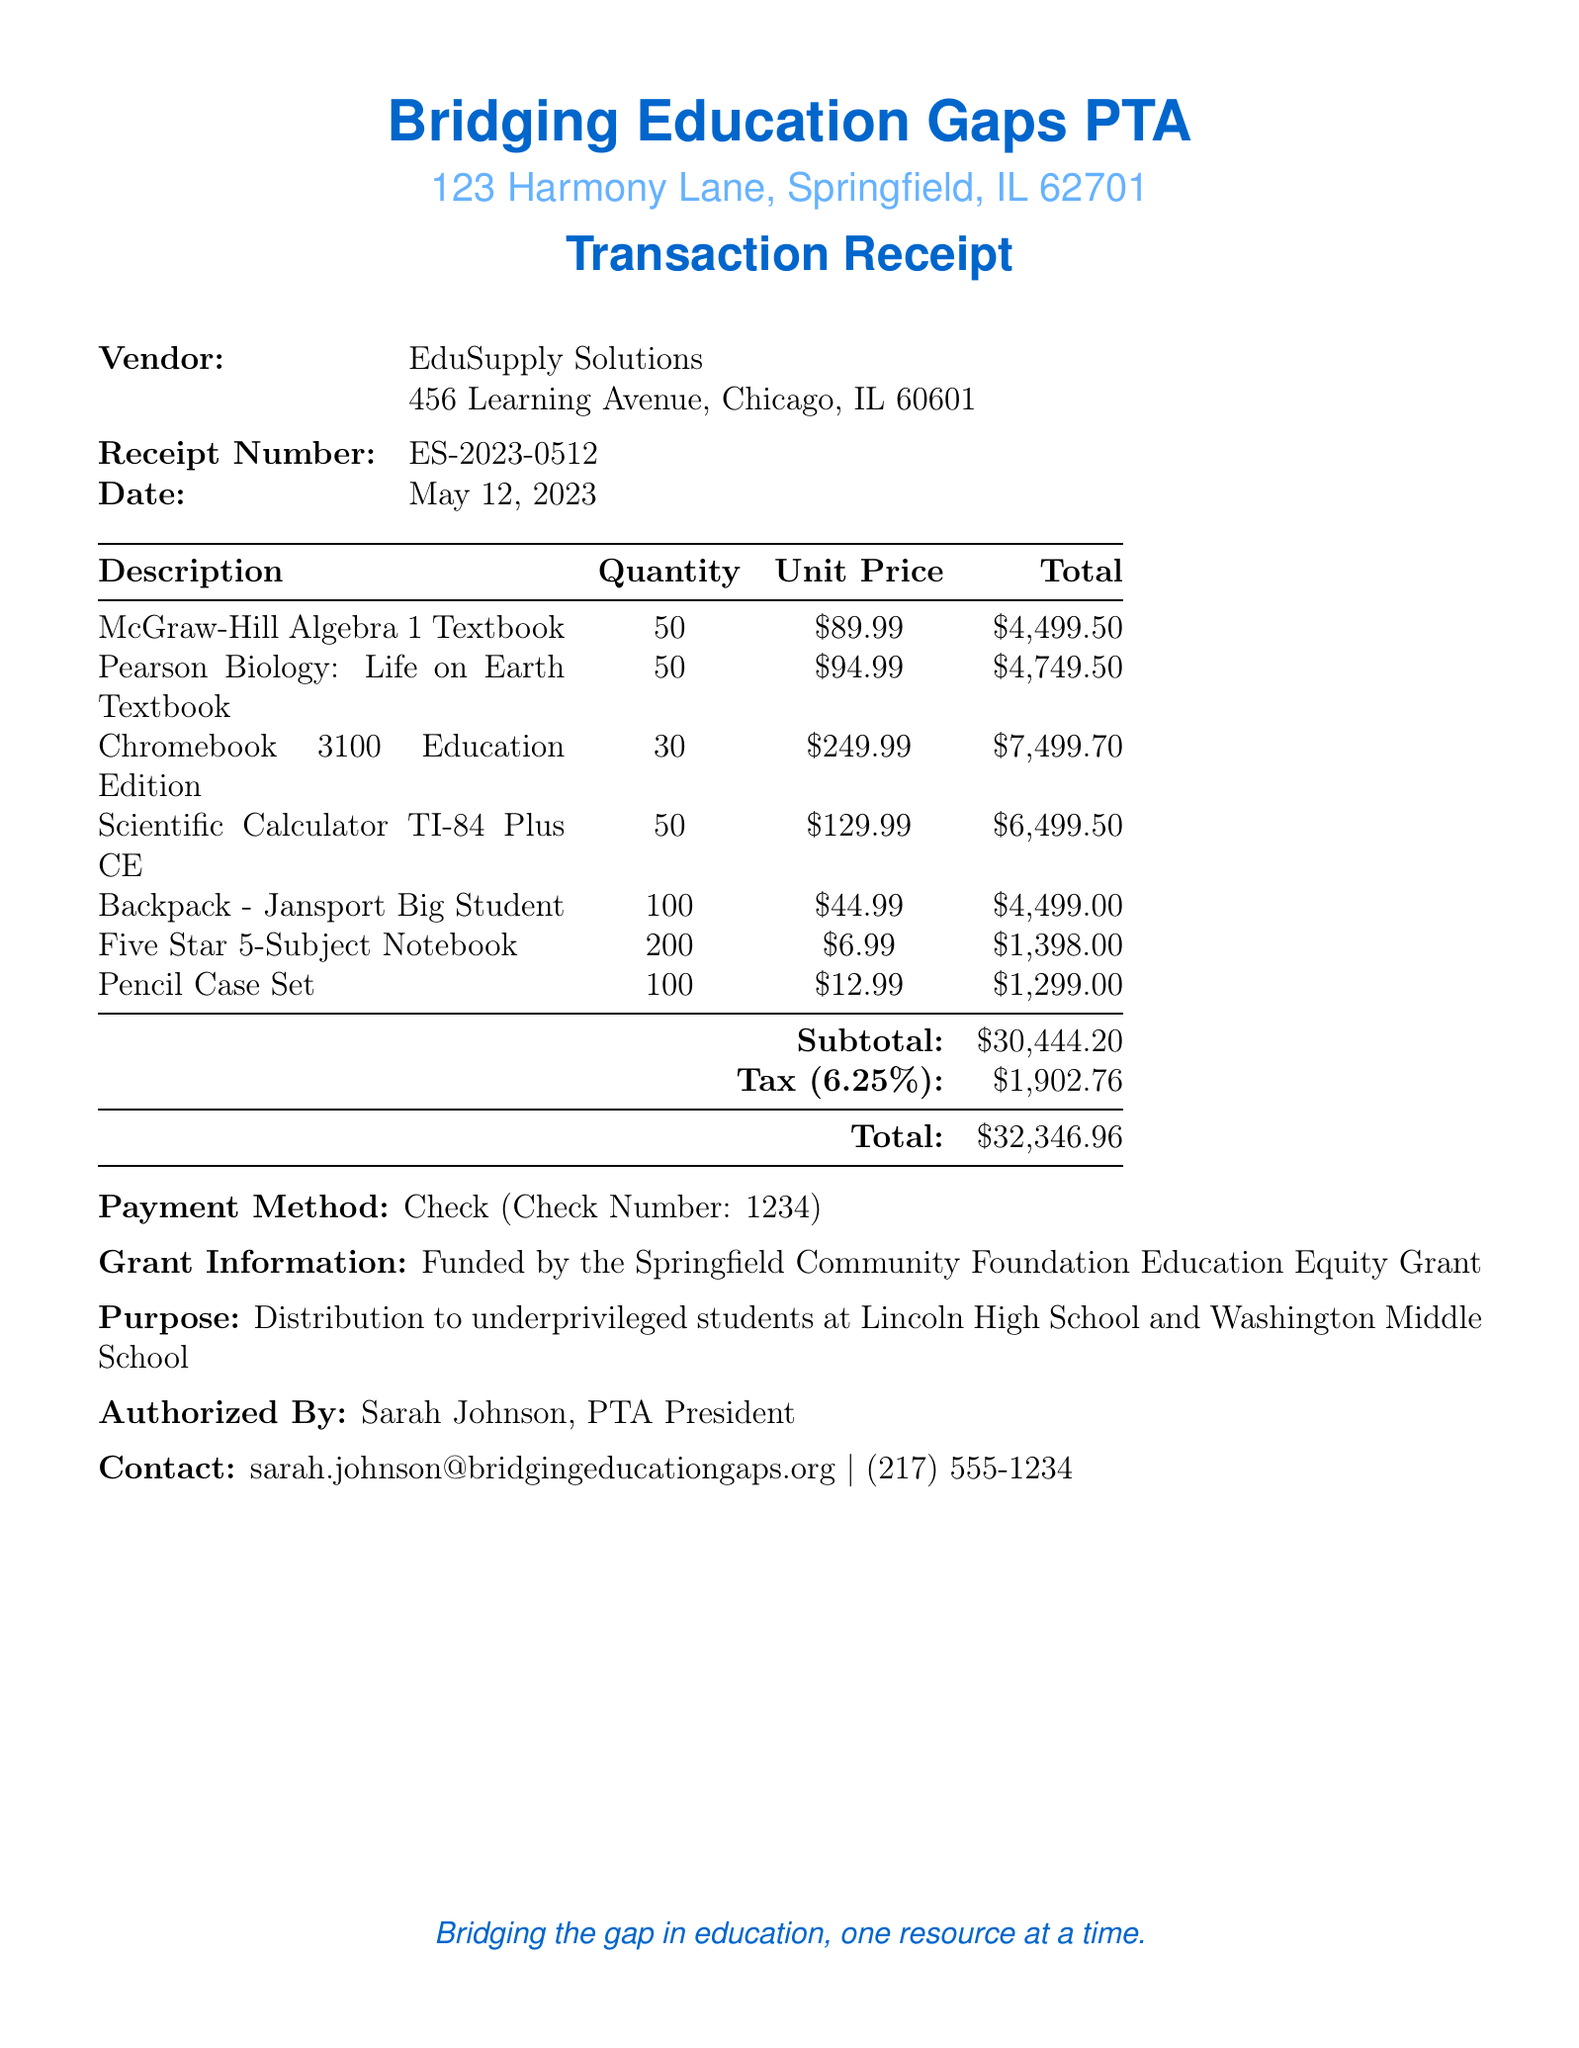What is the name of the organization? The name of the organization is stated at the top of the document.
Answer: Bridging Education Gaps PTA What is the receipt number? The receipt number is indicated in the transaction details section of the document.
Answer: ES-2023-0512 What is the date of the transaction? The date can be found in the transaction details section of the document.
Answer: May 12, 2023 How many Chromebook devices were purchased? The quantity of Chromebook devices is detailed in the items list.
Answer: 30 What is the subtotal of the transaction? The subtotal is listed before tax in the financial summary of the document.
Answer: $30,444.20 Who authorized the purchase? The name of the individual who authorized the purchase is noted near the end of the document.
Answer: Sarah Johnson, PTA President What is the total amount spent? The total amount is calculated after adding tax to the subtotal and is found at the bottom of the financial summary.
Answer: $32,346.96 What is the purpose of this transaction? The purpose is described in a specific statement in the document.
Answer: Distribution to underprivileged students at Lincoln High School and Washington Middle School Who is the vendor for the educational resources? The vendor name is listed prominently in the transaction details section.
Answer: EduSupply Solutions What payment method was used? The payment method is stated clearly in the financial summary section.
Answer: Check 